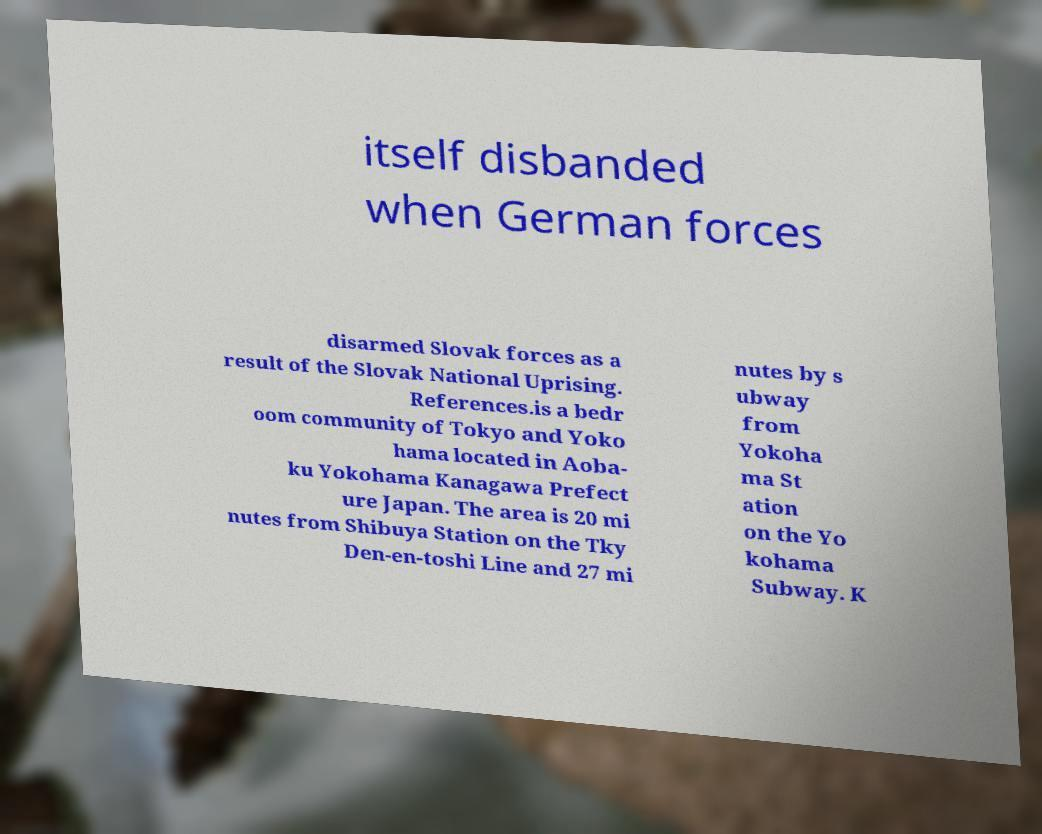Can you read and provide the text displayed in the image?This photo seems to have some interesting text. Can you extract and type it out for me? itself disbanded when German forces disarmed Slovak forces as a result of the Slovak National Uprising. References.is a bedr oom community of Tokyo and Yoko hama located in Aoba- ku Yokohama Kanagawa Prefect ure Japan. The area is 20 mi nutes from Shibuya Station on the Tky Den-en-toshi Line and 27 mi nutes by s ubway from Yokoha ma St ation on the Yo kohama Subway. K 